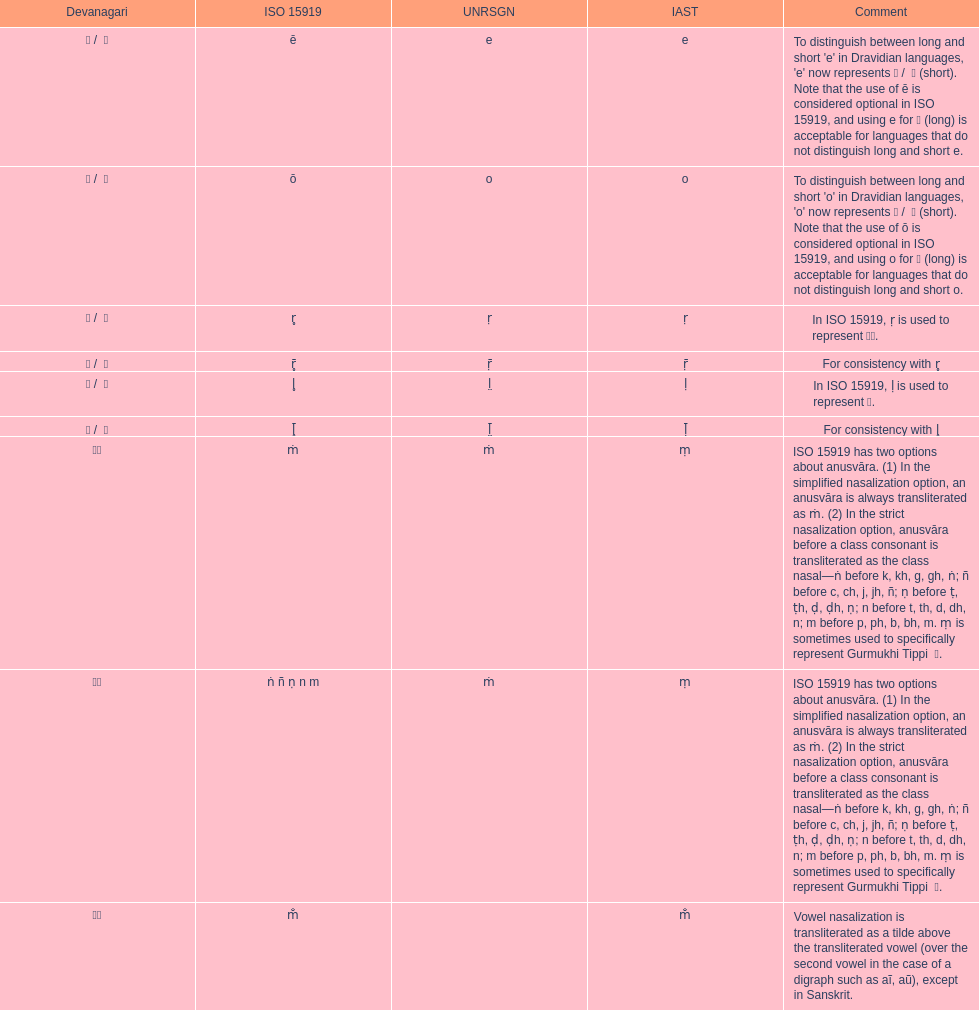What is the cumulative number of translations? 8. 